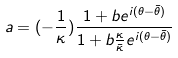<formula> <loc_0><loc_0><loc_500><loc_500>a = ( - \frac { 1 } { \kappa } ) \frac { 1 + b e ^ { i ( \theta - \bar { \theta } ) } } { 1 + b \frac { \kappa } { \bar { \kappa } } e ^ { i ( \theta - \bar { \theta } ) } }</formula> 